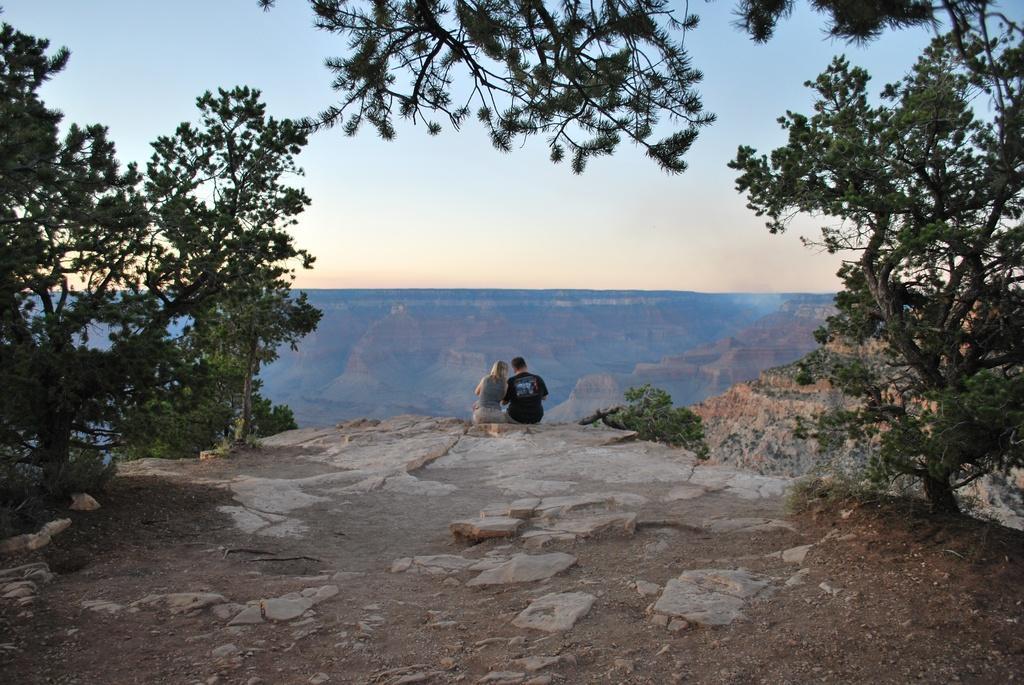Can you describe this image briefly? In this image there is a couple sitting on the hill. On the left and right side of the image there are trees. In the background there are hills and the sky. 